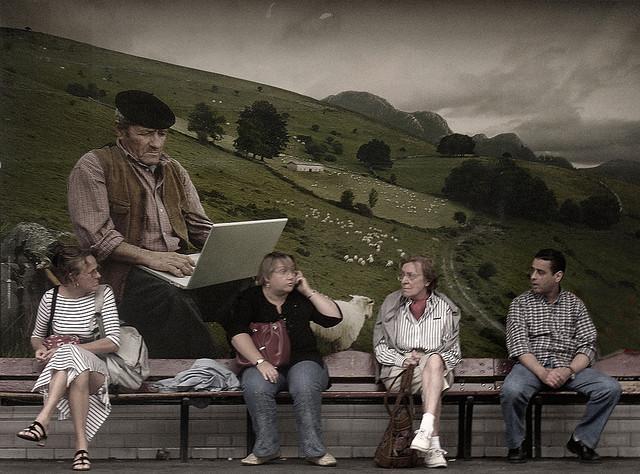How many people are there?
Give a very brief answer. 5. How many handbags are in the picture?
Give a very brief answer. 2. 